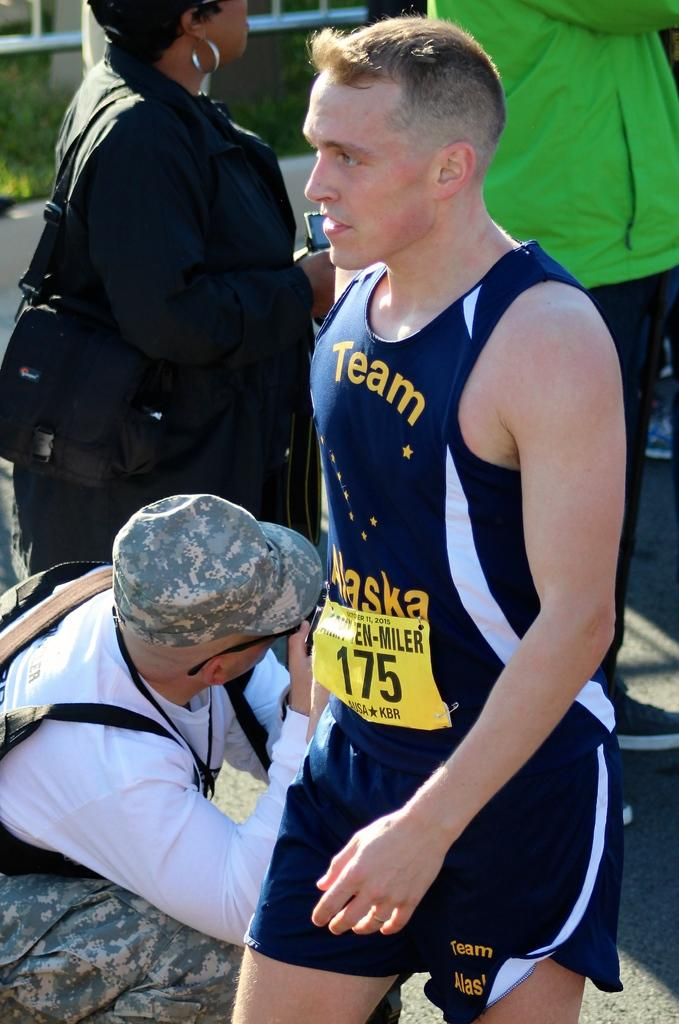<image>
Create a compact narrative representing the image presented. A man wearing a running outfit that has the numerals 175 on the front. 